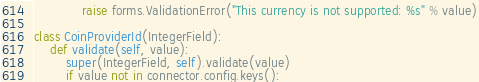<code> <loc_0><loc_0><loc_500><loc_500><_Python_>            raise forms.ValidationError("This currency is not supported: %s" % value)

class CoinProviderId(IntegerField):
    def validate(self, value):
        super(IntegerField, self).validate(value)
        if value not in connector.config.keys():</code> 